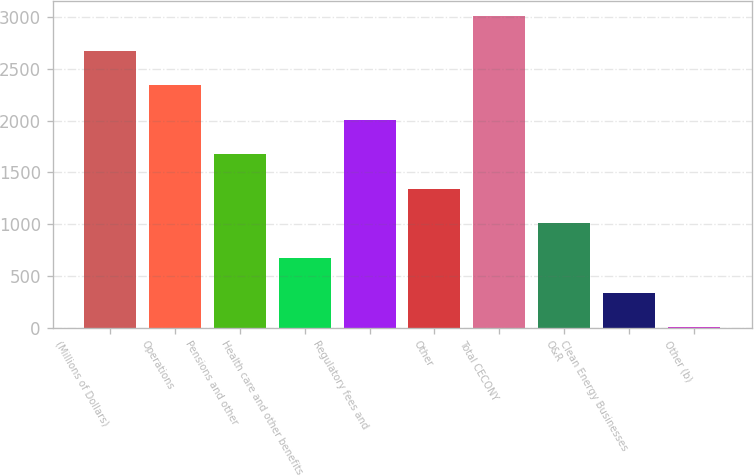Convert chart to OTSL. <chart><loc_0><loc_0><loc_500><loc_500><bar_chart><fcel>(Millions of Dollars)<fcel>Operations<fcel>Pensions and other<fcel>Health care and other benefits<fcel>Regulatory fees and<fcel>Other<fcel>Total CECONY<fcel>O&R<fcel>Clean Energy Businesses<fcel>Other (b)<nl><fcel>2676<fcel>2342<fcel>1674<fcel>672<fcel>2008<fcel>1340<fcel>3010<fcel>1006<fcel>338<fcel>4<nl></chart> 